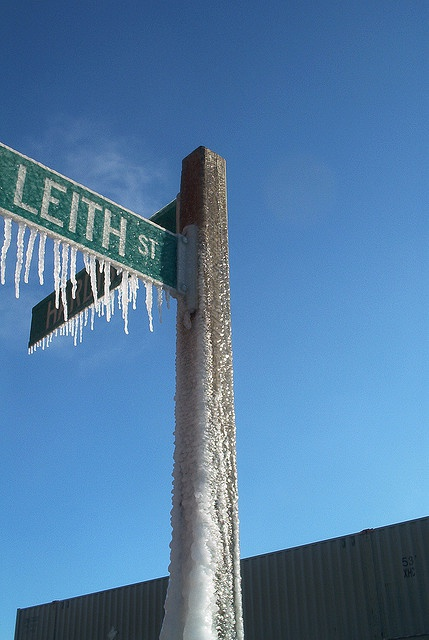Describe the objects in this image and their specific colors. I can see various objects in this image with different colors. 